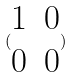Convert formula to latex. <formula><loc_0><loc_0><loc_500><loc_500>( \begin{matrix} 1 & 0 \\ 0 & 0 \end{matrix} )</formula> 